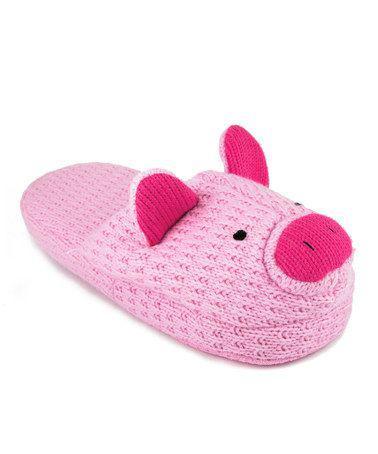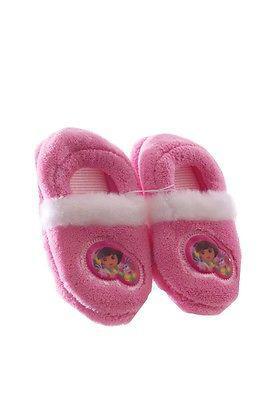The first image is the image on the left, the second image is the image on the right. Given the left and right images, does the statement "Two pairs of slippers are pink, but different styles, one of them a solid pink color with same color furry trim element." hold true? Answer yes or no. No. The first image is the image on the left, the second image is the image on the right. Considering the images on both sides, is "The left image features a slipper style with an animal face on the top, and the right image shows a matching pair of fur-trimmed slippers." valid? Answer yes or no. Yes. 